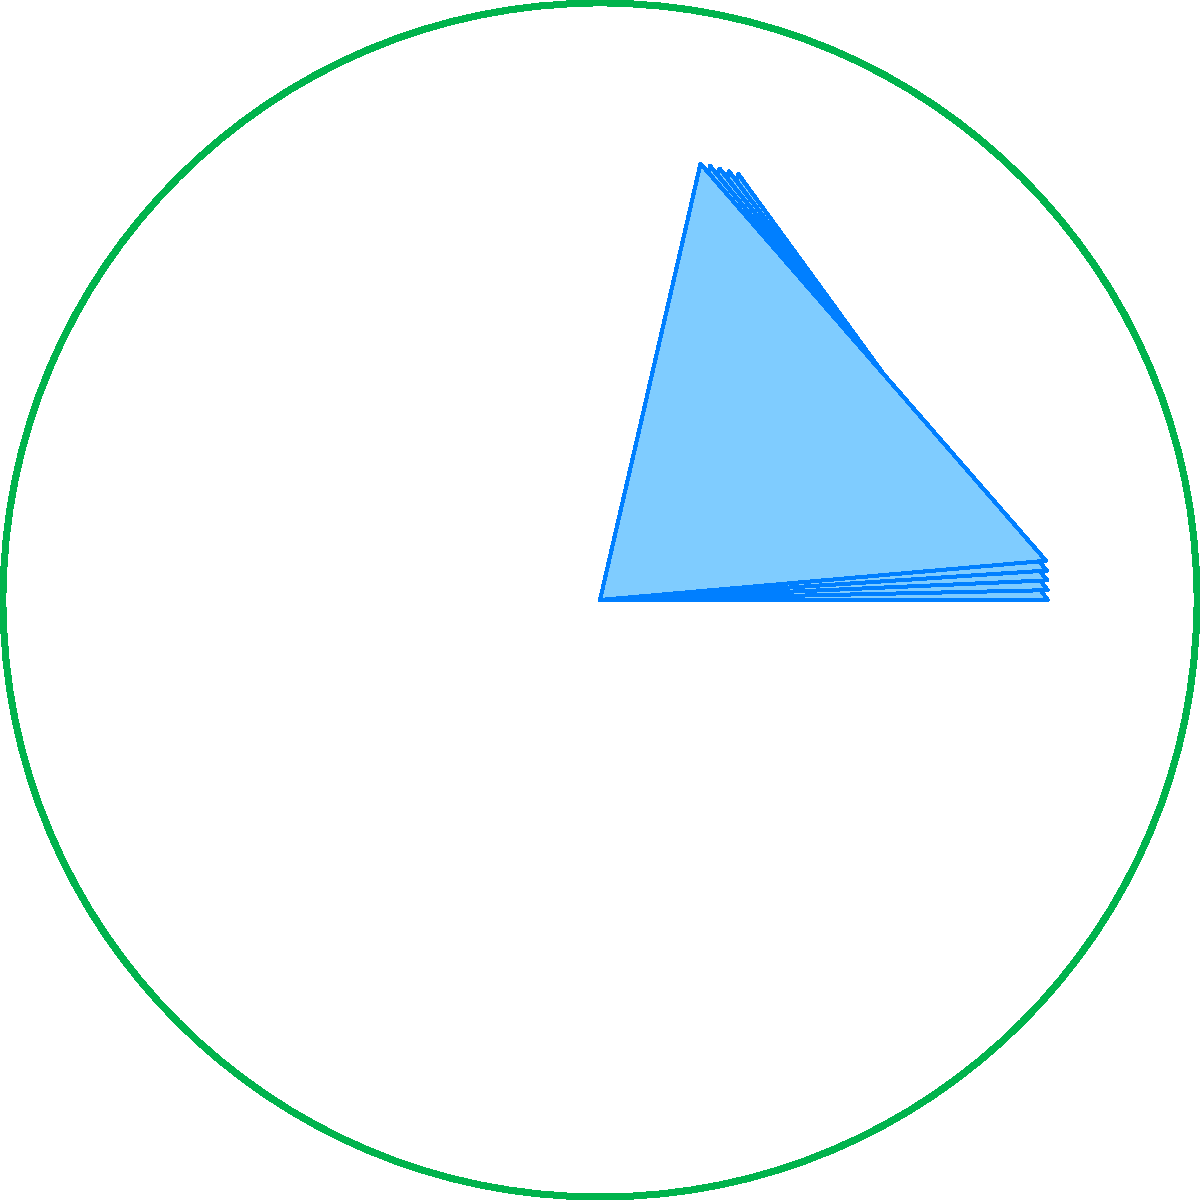In the movie "Annihilation", the shimmer is characterized by intricate geometric patterns. The image above represents a simplified version of these patterns. How many complete iterations of the fractal shape would be required to form a perfect pentagonal symmetry around the central point? To answer this question, let's analyze the geometric pattern step-by-step:

1. The image shows a circular boundary with fractal shapes inside.
2. Each fractal shape is a triangular formation.
3. The fractals are arranged around a central point.
4. Currently, we can see 5 fractal shapes in the image.
5. These 5 shapes do not completely fill the circle; there are gaps between them.
6. To achieve perfect pentagonal symmetry, we need to consider the properties of a regular pentagon:
   - A regular pentagon has 5 equal sides and 5 equal angles.
   - The internal angle of a regular pentagon is $(540°/5) = 108°$.
7. In the current arrangement, the fractals are separated by gaps of $(360°/5) = 72°$.
8. To fill these gaps and create perfect symmetry, we need to add one more iteration of fractals in between each existing fractal.
9. This would mean adding 5 more fractal shapes, bringing the total to 10.
10. With 10 fractal shapes, each would occupy $(360°/10) = 36°$, which is exactly one-third of the $108°$ internal angle of a regular pentagon.

Therefore, we need 2 complete iterations (the original 5 plus 5 more) to form a perfect pentagonal symmetry around the central point.
Answer: 2 iterations 